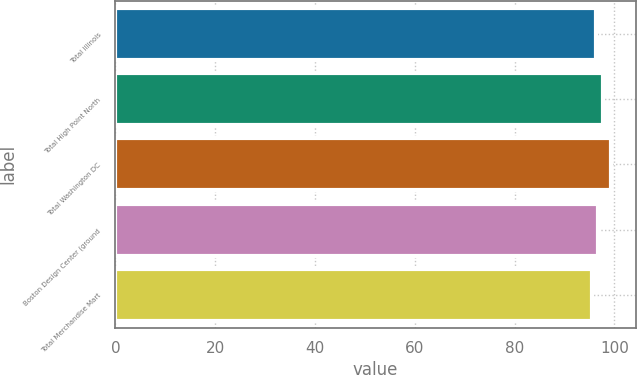Convert chart to OTSL. <chart><loc_0><loc_0><loc_500><loc_500><bar_chart><fcel>Total Illinois<fcel>Total High Point North<fcel>Total Washington DC<fcel>Boston Design Center (ground<fcel>Total Merchandise Mart<nl><fcel>96.3<fcel>97.6<fcel>99.3<fcel>96.68<fcel>95.5<nl></chart> 